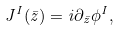<formula> <loc_0><loc_0><loc_500><loc_500>J ^ { I } ( \bar { z } ) = i \partial _ { \bar { z } } \phi ^ { I } ,</formula> 